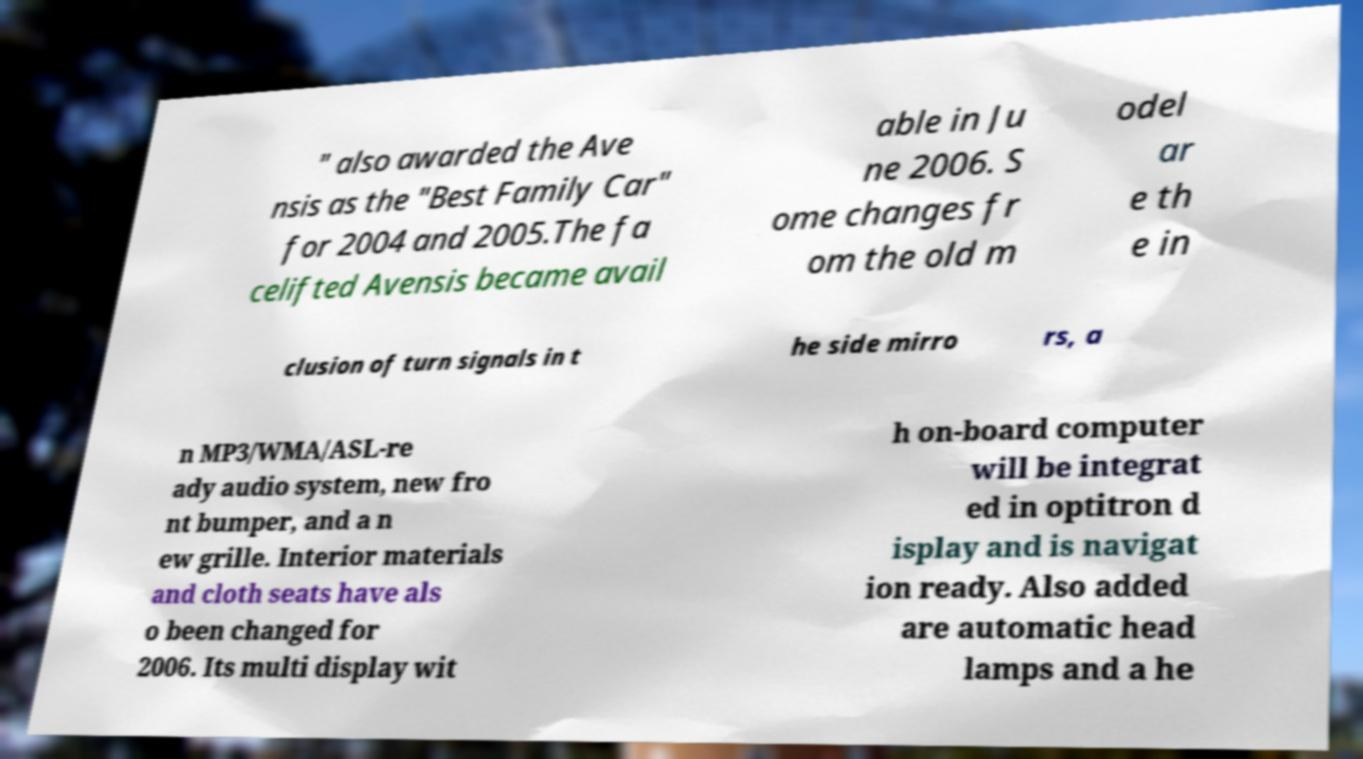There's text embedded in this image that I need extracted. Can you transcribe it verbatim? " also awarded the Ave nsis as the "Best Family Car" for 2004 and 2005.The fa celifted Avensis became avail able in Ju ne 2006. S ome changes fr om the old m odel ar e th e in clusion of turn signals in t he side mirro rs, a n MP3/WMA/ASL-re ady audio system, new fro nt bumper, and a n ew grille. Interior materials and cloth seats have als o been changed for 2006. Its multi display wit h on-board computer will be integrat ed in optitron d isplay and is navigat ion ready. Also added are automatic head lamps and a he 